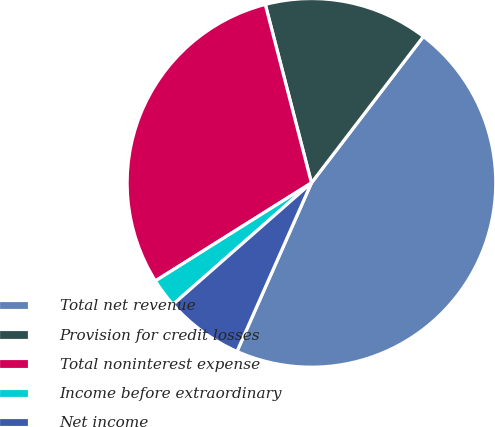<chart> <loc_0><loc_0><loc_500><loc_500><pie_chart><fcel>Total net revenue<fcel>Provision for credit losses<fcel>Total noninterest expense<fcel>Income before extraordinary<fcel>Net income<nl><fcel>46.23%<fcel>14.42%<fcel>29.9%<fcel>2.54%<fcel>6.91%<nl></chart> 